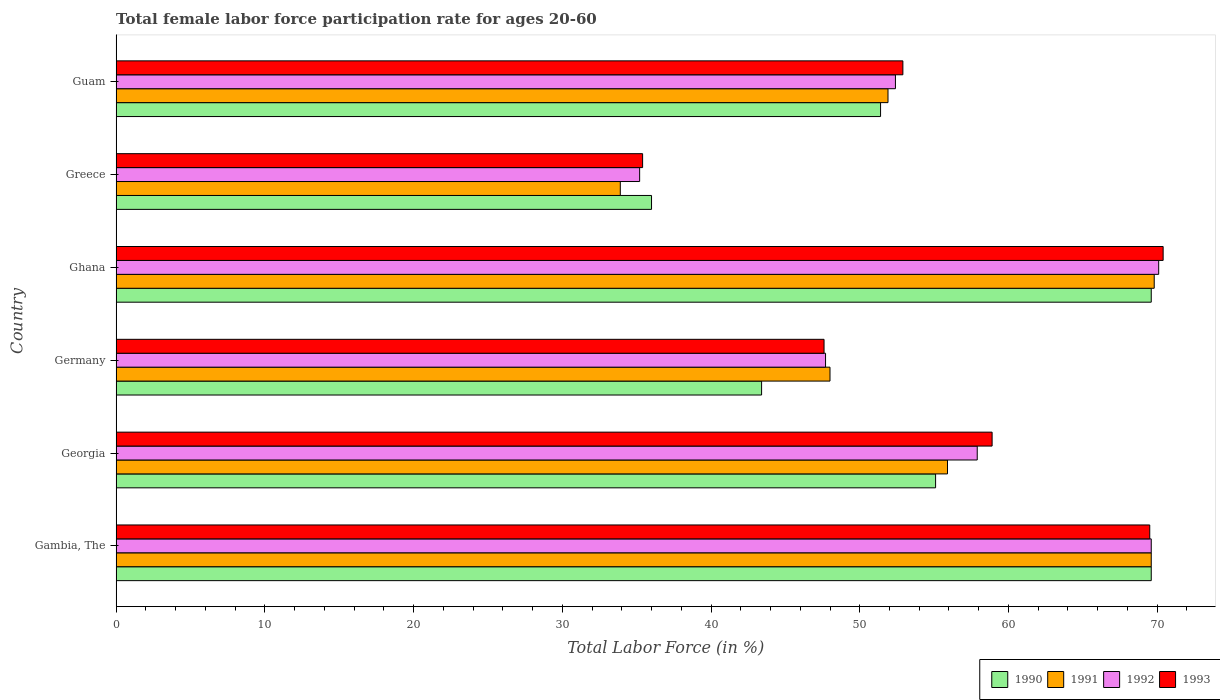How many different coloured bars are there?
Your response must be concise. 4. How many groups of bars are there?
Offer a very short reply. 6. Are the number of bars on each tick of the Y-axis equal?
Provide a short and direct response. Yes. How many bars are there on the 3rd tick from the top?
Make the answer very short. 4. What is the label of the 1st group of bars from the top?
Your answer should be very brief. Guam. In how many cases, is the number of bars for a given country not equal to the number of legend labels?
Offer a terse response. 0. What is the female labor force participation rate in 1992 in Gambia, The?
Offer a very short reply. 69.6. Across all countries, what is the maximum female labor force participation rate in 1993?
Offer a very short reply. 70.4. Across all countries, what is the minimum female labor force participation rate in 1991?
Offer a terse response. 33.9. In which country was the female labor force participation rate in 1990 minimum?
Make the answer very short. Greece. What is the total female labor force participation rate in 1991 in the graph?
Keep it short and to the point. 329.1. What is the average female labor force participation rate in 1991 per country?
Keep it short and to the point. 54.85. What is the difference between the female labor force participation rate in 1992 and female labor force participation rate in 1993 in Ghana?
Provide a succinct answer. -0.3. In how many countries, is the female labor force participation rate in 1990 greater than 34 %?
Keep it short and to the point. 6. What is the ratio of the female labor force participation rate in 1993 in Ghana to that in Greece?
Offer a terse response. 1.99. Is the female labor force participation rate in 1990 in Georgia less than that in Ghana?
Provide a short and direct response. Yes. What is the difference between the highest and the lowest female labor force participation rate in 1990?
Ensure brevity in your answer.  33.6. Is it the case that in every country, the sum of the female labor force participation rate in 1993 and female labor force participation rate in 1991 is greater than the sum of female labor force participation rate in 1992 and female labor force participation rate in 1990?
Keep it short and to the point. No. What does the 3rd bar from the top in Germany represents?
Your response must be concise. 1991. How many bars are there?
Offer a terse response. 24. Are all the bars in the graph horizontal?
Offer a terse response. Yes. What is the difference between two consecutive major ticks on the X-axis?
Give a very brief answer. 10. Are the values on the major ticks of X-axis written in scientific E-notation?
Make the answer very short. No. Does the graph contain any zero values?
Offer a very short reply. No. Does the graph contain grids?
Provide a succinct answer. No. Where does the legend appear in the graph?
Your answer should be very brief. Bottom right. How many legend labels are there?
Offer a terse response. 4. How are the legend labels stacked?
Provide a succinct answer. Horizontal. What is the title of the graph?
Give a very brief answer. Total female labor force participation rate for ages 20-60. What is the label or title of the X-axis?
Keep it short and to the point. Total Labor Force (in %). What is the label or title of the Y-axis?
Ensure brevity in your answer.  Country. What is the Total Labor Force (in %) of 1990 in Gambia, The?
Offer a terse response. 69.6. What is the Total Labor Force (in %) of 1991 in Gambia, The?
Provide a short and direct response. 69.6. What is the Total Labor Force (in %) of 1992 in Gambia, The?
Offer a very short reply. 69.6. What is the Total Labor Force (in %) in 1993 in Gambia, The?
Your answer should be very brief. 69.5. What is the Total Labor Force (in %) in 1990 in Georgia?
Give a very brief answer. 55.1. What is the Total Labor Force (in %) in 1991 in Georgia?
Make the answer very short. 55.9. What is the Total Labor Force (in %) in 1992 in Georgia?
Your response must be concise. 57.9. What is the Total Labor Force (in %) of 1993 in Georgia?
Make the answer very short. 58.9. What is the Total Labor Force (in %) in 1990 in Germany?
Your answer should be very brief. 43.4. What is the Total Labor Force (in %) of 1992 in Germany?
Provide a succinct answer. 47.7. What is the Total Labor Force (in %) in 1993 in Germany?
Your answer should be compact. 47.6. What is the Total Labor Force (in %) of 1990 in Ghana?
Provide a succinct answer. 69.6. What is the Total Labor Force (in %) in 1991 in Ghana?
Keep it short and to the point. 69.8. What is the Total Labor Force (in %) in 1992 in Ghana?
Provide a succinct answer. 70.1. What is the Total Labor Force (in %) in 1993 in Ghana?
Provide a succinct answer. 70.4. What is the Total Labor Force (in %) in 1991 in Greece?
Provide a succinct answer. 33.9. What is the Total Labor Force (in %) in 1992 in Greece?
Make the answer very short. 35.2. What is the Total Labor Force (in %) of 1993 in Greece?
Provide a short and direct response. 35.4. What is the Total Labor Force (in %) of 1990 in Guam?
Your response must be concise. 51.4. What is the Total Labor Force (in %) of 1991 in Guam?
Keep it short and to the point. 51.9. What is the Total Labor Force (in %) of 1992 in Guam?
Make the answer very short. 52.4. What is the Total Labor Force (in %) of 1993 in Guam?
Give a very brief answer. 52.9. Across all countries, what is the maximum Total Labor Force (in %) of 1990?
Keep it short and to the point. 69.6. Across all countries, what is the maximum Total Labor Force (in %) in 1991?
Offer a very short reply. 69.8. Across all countries, what is the maximum Total Labor Force (in %) of 1992?
Make the answer very short. 70.1. Across all countries, what is the maximum Total Labor Force (in %) of 1993?
Your answer should be very brief. 70.4. Across all countries, what is the minimum Total Labor Force (in %) of 1991?
Ensure brevity in your answer.  33.9. Across all countries, what is the minimum Total Labor Force (in %) of 1992?
Provide a succinct answer. 35.2. Across all countries, what is the minimum Total Labor Force (in %) of 1993?
Provide a short and direct response. 35.4. What is the total Total Labor Force (in %) of 1990 in the graph?
Offer a terse response. 325.1. What is the total Total Labor Force (in %) in 1991 in the graph?
Ensure brevity in your answer.  329.1. What is the total Total Labor Force (in %) of 1992 in the graph?
Offer a very short reply. 332.9. What is the total Total Labor Force (in %) of 1993 in the graph?
Provide a succinct answer. 334.7. What is the difference between the Total Labor Force (in %) of 1991 in Gambia, The and that in Georgia?
Provide a succinct answer. 13.7. What is the difference between the Total Labor Force (in %) of 1992 in Gambia, The and that in Georgia?
Ensure brevity in your answer.  11.7. What is the difference between the Total Labor Force (in %) in 1990 in Gambia, The and that in Germany?
Ensure brevity in your answer.  26.2. What is the difference between the Total Labor Force (in %) in 1991 in Gambia, The and that in Germany?
Keep it short and to the point. 21.6. What is the difference between the Total Labor Force (in %) of 1992 in Gambia, The and that in Germany?
Make the answer very short. 21.9. What is the difference between the Total Labor Force (in %) in 1993 in Gambia, The and that in Germany?
Your answer should be compact. 21.9. What is the difference between the Total Labor Force (in %) in 1990 in Gambia, The and that in Ghana?
Keep it short and to the point. 0. What is the difference between the Total Labor Force (in %) in 1991 in Gambia, The and that in Ghana?
Provide a short and direct response. -0.2. What is the difference between the Total Labor Force (in %) of 1990 in Gambia, The and that in Greece?
Offer a very short reply. 33.6. What is the difference between the Total Labor Force (in %) in 1991 in Gambia, The and that in Greece?
Your answer should be very brief. 35.7. What is the difference between the Total Labor Force (in %) in 1992 in Gambia, The and that in Greece?
Provide a short and direct response. 34.4. What is the difference between the Total Labor Force (in %) in 1993 in Gambia, The and that in Greece?
Ensure brevity in your answer.  34.1. What is the difference between the Total Labor Force (in %) in 1991 in Gambia, The and that in Guam?
Give a very brief answer. 17.7. What is the difference between the Total Labor Force (in %) of 1992 in Georgia and that in Germany?
Your answer should be compact. 10.2. What is the difference between the Total Labor Force (in %) in 1993 in Georgia and that in Germany?
Keep it short and to the point. 11.3. What is the difference between the Total Labor Force (in %) of 1992 in Georgia and that in Ghana?
Your response must be concise. -12.2. What is the difference between the Total Labor Force (in %) of 1993 in Georgia and that in Ghana?
Offer a terse response. -11.5. What is the difference between the Total Labor Force (in %) in 1992 in Georgia and that in Greece?
Ensure brevity in your answer.  22.7. What is the difference between the Total Labor Force (in %) in 1993 in Georgia and that in Greece?
Provide a short and direct response. 23.5. What is the difference between the Total Labor Force (in %) of 1991 in Georgia and that in Guam?
Make the answer very short. 4. What is the difference between the Total Labor Force (in %) in 1993 in Georgia and that in Guam?
Provide a succinct answer. 6. What is the difference between the Total Labor Force (in %) in 1990 in Germany and that in Ghana?
Your answer should be compact. -26.2. What is the difference between the Total Labor Force (in %) in 1991 in Germany and that in Ghana?
Offer a very short reply. -21.8. What is the difference between the Total Labor Force (in %) in 1992 in Germany and that in Ghana?
Offer a very short reply. -22.4. What is the difference between the Total Labor Force (in %) in 1993 in Germany and that in Ghana?
Ensure brevity in your answer.  -22.8. What is the difference between the Total Labor Force (in %) of 1990 in Germany and that in Greece?
Give a very brief answer. 7.4. What is the difference between the Total Labor Force (in %) of 1991 in Germany and that in Greece?
Your answer should be very brief. 14.1. What is the difference between the Total Labor Force (in %) in 1993 in Germany and that in Greece?
Your answer should be very brief. 12.2. What is the difference between the Total Labor Force (in %) of 1990 in Germany and that in Guam?
Offer a very short reply. -8. What is the difference between the Total Labor Force (in %) in 1992 in Germany and that in Guam?
Ensure brevity in your answer.  -4.7. What is the difference between the Total Labor Force (in %) of 1990 in Ghana and that in Greece?
Provide a succinct answer. 33.6. What is the difference between the Total Labor Force (in %) in 1991 in Ghana and that in Greece?
Your answer should be very brief. 35.9. What is the difference between the Total Labor Force (in %) in 1992 in Ghana and that in Greece?
Keep it short and to the point. 34.9. What is the difference between the Total Labor Force (in %) in 1990 in Ghana and that in Guam?
Your answer should be compact. 18.2. What is the difference between the Total Labor Force (in %) of 1992 in Ghana and that in Guam?
Your answer should be very brief. 17.7. What is the difference between the Total Labor Force (in %) in 1990 in Greece and that in Guam?
Keep it short and to the point. -15.4. What is the difference between the Total Labor Force (in %) of 1991 in Greece and that in Guam?
Provide a short and direct response. -18. What is the difference between the Total Labor Force (in %) in 1992 in Greece and that in Guam?
Keep it short and to the point. -17.2. What is the difference between the Total Labor Force (in %) in 1993 in Greece and that in Guam?
Offer a terse response. -17.5. What is the difference between the Total Labor Force (in %) in 1990 in Gambia, The and the Total Labor Force (in %) in 1991 in Georgia?
Offer a terse response. 13.7. What is the difference between the Total Labor Force (in %) of 1991 in Gambia, The and the Total Labor Force (in %) of 1993 in Georgia?
Make the answer very short. 10.7. What is the difference between the Total Labor Force (in %) of 1992 in Gambia, The and the Total Labor Force (in %) of 1993 in Georgia?
Your response must be concise. 10.7. What is the difference between the Total Labor Force (in %) of 1990 in Gambia, The and the Total Labor Force (in %) of 1991 in Germany?
Provide a succinct answer. 21.6. What is the difference between the Total Labor Force (in %) of 1990 in Gambia, The and the Total Labor Force (in %) of 1992 in Germany?
Provide a short and direct response. 21.9. What is the difference between the Total Labor Force (in %) in 1990 in Gambia, The and the Total Labor Force (in %) in 1993 in Germany?
Give a very brief answer. 22. What is the difference between the Total Labor Force (in %) of 1991 in Gambia, The and the Total Labor Force (in %) of 1992 in Germany?
Your response must be concise. 21.9. What is the difference between the Total Labor Force (in %) in 1990 in Gambia, The and the Total Labor Force (in %) in 1991 in Ghana?
Provide a succinct answer. -0.2. What is the difference between the Total Labor Force (in %) in 1992 in Gambia, The and the Total Labor Force (in %) in 1993 in Ghana?
Your answer should be very brief. -0.8. What is the difference between the Total Labor Force (in %) of 1990 in Gambia, The and the Total Labor Force (in %) of 1991 in Greece?
Your answer should be compact. 35.7. What is the difference between the Total Labor Force (in %) of 1990 in Gambia, The and the Total Labor Force (in %) of 1992 in Greece?
Offer a terse response. 34.4. What is the difference between the Total Labor Force (in %) of 1990 in Gambia, The and the Total Labor Force (in %) of 1993 in Greece?
Your answer should be compact. 34.2. What is the difference between the Total Labor Force (in %) of 1991 in Gambia, The and the Total Labor Force (in %) of 1992 in Greece?
Provide a short and direct response. 34.4. What is the difference between the Total Labor Force (in %) of 1991 in Gambia, The and the Total Labor Force (in %) of 1993 in Greece?
Ensure brevity in your answer.  34.2. What is the difference between the Total Labor Force (in %) in 1992 in Gambia, The and the Total Labor Force (in %) in 1993 in Greece?
Make the answer very short. 34.2. What is the difference between the Total Labor Force (in %) of 1990 in Gambia, The and the Total Labor Force (in %) of 1991 in Guam?
Your response must be concise. 17.7. What is the difference between the Total Labor Force (in %) in 1990 in Gambia, The and the Total Labor Force (in %) in 1993 in Guam?
Your response must be concise. 16.7. What is the difference between the Total Labor Force (in %) of 1991 in Gambia, The and the Total Labor Force (in %) of 1993 in Guam?
Provide a short and direct response. 16.7. What is the difference between the Total Labor Force (in %) in 1990 in Georgia and the Total Labor Force (in %) in 1992 in Germany?
Keep it short and to the point. 7.4. What is the difference between the Total Labor Force (in %) in 1991 in Georgia and the Total Labor Force (in %) in 1993 in Germany?
Provide a succinct answer. 8.3. What is the difference between the Total Labor Force (in %) of 1992 in Georgia and the Total Labor Force (in %) of 1993 in Germany?
Offer a terse response. 10.3. What is the difference between the Total Labor Force (in %) of 1990 in Georgia and the Total Labor Force (in %) of 1991 in Ghana?
Offer a very short reply. -14.7. What is the difference between the Total Labor Force (in %) of 1990 in Georgia and the Total Labor Force (in %) of 1993 in Ghana?
Offer a terse response. -15.3. What is the difference between the Total Labor Force (in %) of 1991 in Georgia and the Total Labor Force (in %) of 1992 in Ghana?
Your answer should be very brief. -14.2. What is the difference between the Total Labor Force (in %) in 1991 in Georgia and the Total Labor Force (in %) in 1993 in Ghana?
Keep it short and to the point. -14.5. What is the difference between the Total Labor Force (in %) of 1992 in Georgia and the Total Labor Force (in %) of 1993 in Ghana?
Your answer should be compact. -12.5. What is the difference between the Total Labor Force (in %) in 1990 in Georgia and the Total Labor Force (in %) in 1991 in Greece?
Ensure brevity in your answer.  21.2. What is the difference between the Total Labor Force (in %) in 1990 in Georgia and the Total Labor Force (in %) in 1992 in Greece?
Ensure brevity in your answer.  19.9. What is the difference between the Total Labor Force (in %) in 1990 in Georgia and the Total Labor Force (in %) in 1993 in Greece?
Your response must be concise. 19.7. What is the difference between the Total Labor Force (in %) in 1991 in Georgia and the Total Labor Force (in %) in 1992 in Greece?
Offer a terse response. 20.7. What is the difference between the Total Labor Force (in %) of 1990 in Georgia and the Total Labor Force (in %) of 1991 in Guam?
Offer a terse response. 3.2. What is the difference between the Total Labor Force (in %) of 1991 in Georgia and the Total Labor Force (in %) of 1992 in Guam?
Give a very brief answer. 3.5. What is the difference between the Total Labor Force (in %) of 1990 in Germany and the Total Labor Force (in %) of 1991 in Ghana?
Make the answer very short. -26.4. What is the difference between the Total Labor Force (in %) of 1990 in Germany and the Total Labor Force (in %) of 1992 in Ghana?
Your answer should be compact. -26.7. What is the difference between the Total Labor Force (in %) in 1991 in Germany and the Total Labor Force (in %) in 1992 in Ghana?
Give a very brief answer. -22.1. What is the difference between the Total Labor Force (in %) in 1991 in Germany and the Total Labor Force (in %) in 1993 in Ghana?
Offer a very short reply. -22.4. What is the difference between the Total Labor Force (in %) of 1992 in Germany and the Total Labor Force (in %) of 1993 in Ghana?
Make the answer very short. -22.7. What is the difference between the Total Labor Force (in %) of 1990 in Germany and the Total Labor Force (in %) of 1991 in Greece?
Your answer should be very brief. 9.5. What is the difference between the Total Labor Force (in %) of 1990 in Germany and the Total Labor Force (in %) of 1992 in Greece?
Your answer should be very brief. 8.2. What is the difference between the Total Labor Force (in %) in 1990 in Germany and the Total Labor Force (in %) in 1993 in Greece?
Provide a succinct answer. 8. What is the difference between the Total Labor Force (in %) in 1991 in Germany and the Total Labor Force (in %) in 1992 in Greece?
Offer a very short reply. 12.8. What is the difference between the Total Labor Force (in %) of 1992 in Germany and the Total Labor Force (in %) of 1993 in Greece?
Offer a terse response. 12.3. What is the difference between the Total Labor Force (in %) in 1990 in Germany and the Total Labor Force (in %) in 1991 in Guam?
Provide a succinct answer. -8.5. What is the difference between the Total Labor Force (in %) in 1990 in Germany and the Total Labor Force (in %) in 1992 in Guam?
Offer a very short reply. -9. What is the difference between the Total Labor Force (in %) of 1990 in Germany and the Total Labor Force (in %) of 1993 in Guam?
Ensure brevity in your answer.  -9.5. What is the difference between the Total Labor Force (in %) of 1991 in Germany and the Total Labor Force (in %) of 1992 in Guam?
Provide a succinct answer. -4.4. What is the difference between the Total Labor Force (in %) in 1991 in Germany and the Total Labor Force (in %) in 1993 in Guam?
Offer a terse response. -4.9. What is the difference between the Total Labor Force (in %) of 1992 in Germany and the Total Labor Force (in %) of 1993 in Guam?
Your response must be concise. -5.2. What is the difference between the Total Labor Force (in %) of 1990 in Ghana and the Total Labor Force (in %) of 1991 in Greece?
Offer a very short reply. 35.7. What is the difference between the Total Labor Force (in %) of 1990 in Ghana and the Total Labor Force (in %) of 1992 in Greece?
Your response must be concise. 34.4. What is the difference between the Total Labor Force (in %) in 1990 in Ghana and the Total Labor Force (in %) in 1993 in Greece?
Offer a terse response. 34.2. What is the difference between the Total Labor Force (in %) of 1991 in Ghana and the Total Labor Force (in %) of 1992 in Greece?
Your response must be concise. 34.6. What is the difference between the Total Labor Force (in %) of 1991 in Ghana and the Total Labor Force (in %) of 1993 in Greece?
Your answer should be compact. 34.4. What is the difference between the Total Labor Force (in %) of 1992 in Ghana and the Total Labor Force (in %) of 1993 in Greece?
Give a very brief answer. 34.7. What is the difference between the Total Labor Force (in %) in 1990 in Ghana and the Total Labor Force (in %) in 1992 in Guam?
Keep it short and to the point. 17.2. What is the difference between the Total Labor Force (in %) of 1992 in Ghana and the Total Labor Force (in %) of 1993 in Guam?
Offer a very short reply. 17.2. What is the difference between the Total Labor Force (in %) in 1990 in Greece and the Total Labor Force (in %) in 1991 in Guam?
Make the answer very short. -15.9. What is the difference between the Total Labor Force (in %) in 1990 in Greece and the Total Labor Force (in %) in 1992 in Guam?
Provide a succinct answer. -16.4. What is the difference between the Total Labor Force (in %) of 1990 in Greece and the Total Labor Force (in %) of 1993 in Guam?
Provide a short and direct response. -16.9. What is the difference between the Total Labor Force (in %) of 1991 in Greece and the Total Labor Force (in %) of 1992 in Guam?
Offer a very short reply. -18.5. What is the difference between the Total Labor Force (in %) of 1992 in Greece and the Total Labor Force (in %) of 1993 in Guam?
Offer a very short reply. -17.7. What is the average Total Labor Force (in %) of 1990 per country?
Provide a succinct answer. 54.18. What is the average Total Labor Force (in %) in 1991 per country?
Provide a succinct answer. 54.85. What is the average Total Labor Force (in %) of 1992 per country?
Offer a terse response. 55.48. What is the average Total Labor Force (in %) of 1993 per country?
Provide a short and direct response. 55.78. What is the difference between the Total Labor Force (in %) in 1990 and Total Labor Force (in %) in 1991 in Gambia, The?
Provide a succinct answer. 0. What is the difference between the Total Labor Force (in %) in 1990 and Total Labor Force (in %) in 1992 in Gambia, The?
Ensure brevity in your answer.  0. What is the difference between the Total Labor Force (in %) of 1991 and Total Labor Force (in %) of 1993 in Gambia, The?
Offer a very short reply. 0.1. What is the difference between the Total Labor Force (in %) of 1992 and Total Labor Force (in %) of 1993 in Gambia, The?
Ensure brevity in your answer.  0.1. What is the difference between the Total Labor Force (in %) of 1990 and Total Labor Force (in %) of 1991 in Georgia?
Your answer should be compact. -0.8. What is the difference between the Total Labor Force (in %) in 1990 and Total Labor Force (in %) in 1993 in Georgia?
Keep it short and to the point. -3.8. What is the difference between the Total Labor Force (in %) of 1992 and Total Labor Force (in %) of 1993 in Georgia?
Provide a short and direct response. -1. What is the difference between the Total Labor Force (in %) in 1990 and Total Labor Force (in %) in 1991 in Germany?
Your answer should be very brief. -4.6. What is the difference between the Total Labor Force (in %) in 1990 and Total Labor Force (in %) in 1992 in Germany?
Keep it short and to the point. -4.3. What is the difference between the Total Labor Force (in %) in 1990 and Total Labor Force (in %) in 1993 in Ghana?
Offer a very short reply. -0.8. What is the difference between the Total Labor Force (in %) in 1991 and Total Labor Force (in %) in 1992 in Ghana?
Provide a short and direct response. -0.3. What is the difference between the Total Labor Force (in %) of 1992 and Total Labor Force (in %) of 1993 in Ghana?
Offer a very short reply. -0.3. What is the difference between the Total Labor Force (in %) of 1990 and Total Labor Force (in %) of 1992 in Greece?
Ensure brevity in your answer.  0.8. What is the difference between the Total Labor Force (in %) of 1990 and Total Labor Force (in %) of 1993 in Greece?
Keep it short and to the point. 0.6. What is the difference between the Total Labor Force (in %) of 1991 and Total Labor Force (in %) of 1993 in Greece?
Your response must be concise. -1.5. What is the difference between the Total Labor Force (in %) in 1992 and Total Labor Force (in %) in 1993 in Greece?
Provide a succinct answer. -0.2. What is the difference between the Total Labor Force (in %) in 1990 and Total Labor Force (in %) in 1991 in Guam?
Give a very brief answer. -0.5. What is the difference between the Total Labor Force (in %) in 1990 and Total Labor Force (in %) in 1993 in Guam?
Provide a succinct answer. -1.5. What is the difference between the Total Labor Force (in %) in 1992 and Total Labor Force (in %) in 1993 in Guam?
Your answer should be very brief. -0.5. What is the ratio of the Total Labor Force (in %) in 1990 in Gambia, The to that in Georgia?
Your answer should be compact. 1.26. What is the ratio of the Total Labor Force (in %) of 1991 in Gambia, The to that in Georgia?
Your answer should be very brief. 1.25. What is the ratio of the Total Labor Force (in %) in 1992 in Gambia, The to that in Georgia?
Give a very brief answer. 1.2. What is the ratio of the Total Labor Force (in %) of 1993 in Gambia, The to that in Georgia?
Keep it short and to the point. 1.18. What is the ratio of the Total Labor Force (in %) in 1990 in Gambia, The to that in Germany?
Give a very brief answer. 1.6. What is the ratio of the Total Labor Force (in %) in 1991 in Gambia, The to that in Germany?
Your answer should be very brief. 1.45. What is the ratio of the Total Labor Force (in %) of 1992 in Gambia, The to that in Germany?
Provide a short and direct response. 1.46. What is the ratio of the Total Labor Force (in %) in 1993 in Gambia, The to that in Germany?
Keep it short and to the point. 1.46. What is the ratio of the Total Labor Force (in %) of 1990 in Gambia, The to that in Ghana?
Offer a terse response. 1. What is the ratio of the Total Labor Force (in %) of 1991 in Gambia, The to that in Ghana?
Make the answer very short. 1. What is the ratio of the Total Labor Force (in %) of 1992 in Gambia, The to that in Ghana?
Offer a terse response. 0.99. What is the ratio of the Total Labor Force (in %) in 1993 in Gambia, The to that in Ghana?
Make the answer very short. 0.99. What is the ratio of the Total Labor Force (in %) in 1990 in Gambia, The to that in Greece?
Your answer should be very brief. 1.93. What is the ratio of the Total Labor Force (in %) in 1991 in Gambia, The to that in Greece?
Your answer should be very brief. 2.05. What is the ratio of the Total Labor Force (in %) in 1992 in Gambia, The to that in Greece?
Offer a terse response. 1.98. What is the ratio of the Total Labor Force (in %) in 1993 in Gambia, The to that in Greece?
Provide a succinct answer. 1.96. What is the ratio of the Total Labor Force (in %) of 1990 in Gambia, The to that in Guam?
Make the answer very short. 1.35. What is the ratio of the Total Labor Force (in %) in 1991 in Gambia, The to that in Guam?
Offer a very short reply. 1.34. What is the ratio of the Total Labor Force (in %) in 1992 in Gambia, The to that in Guam?
Provide a succinct answer. 1.33. What is the ratio of the Total Labor Force (in %) in 1993 in Gambia, The to that in Guam?
Keep it short and to the point. 1.31. What is the ratio of the Total Labor Force (in %) in 1990 in Georgia to that in Germany?
Your answer should be very brief. 1.27. What is the ratio of the Total Labor Force (in %) in 1991 in Georgia to that in Germany?
Give a very brief answer. 1.16. What is the ratio of the Total Labor Force (in %) of 1992 in Georgia to that in Germany?
Ensure brevity in your answer.  1.21. What is the ratio of the Total Labor Force (in %) of 1993 in Georgia to that in Germany?
Your answer should be very brief. 1.24. What is the ratio of the Total Labor Force (in %) of 1990 in Georgia to that in Ghana?
Offer a very short reply. 0.79. What is the ratio of the Total Labor Force (in %) in 1991 in Georgia to that in Ghana?
Give a very brief answer. 0.8. What is the ratio of the Total Labor Force (in %) in 1992 in Georgia to that in Ghana?
Your answer should be compact. 0.83. What is the ratio of the Total Labor Force (in %) of 1993 in Georgia to that in Ghana?
Make the answer very short. 0.84. What is the ratio of the Total Labor Force (in %) of 1990 in Georgia to that in Greece?
Ensure brevity in your answer.  1.53. What is the ratio of the Total Labor Force (in %) of 1991 in Georgia to that in Greece?
Offer a terse response. 1.65. What is the ratio of the Total Labor Force (in %) of 1992 in Georgia to that in Greece?
Your response must be concise. 1.64. What is the ratio of the Total Labor Force (in %) in 1993 in Georgia to that in Greece?
Give a very brief answer. 1.66. What is the ratio of the Total Labor Force (in %) of 1990 in Georgia to that in Guam?
Your answer should be very brief. 1.07. What is the ratio of the Total Labor Force (in %) of 1991 in Georgia to that in Guam?
Ensure brevity in your answer.  1.08. What is the ratio of the Total Labor Force (in %) in 1992 in Georgia to that in Guam?
Offer a terse response. 1.1. What is the ratio of the Total Labor Force (in %) in 1993 in Georgia to that in Guam?
Offer a terse response. 1.11. What is the ratio of the Total Labor Force (in %) of 1990 in Germany to that in Ghana?
Offer a very short reply. 0.62. What is the ratio of the Total Labor Force (in %) in 1991 in Germany to that in Ghana?
Provide a succinct answer. 0.69. What is the ratio of the Total Labor Force (in %) of 1992 in Germany to that in Ghana?
Provide a short and direct response. 0.68. What is the ratio of the Total Labor Force (in %) of 1993 in Germany to that in Ghana?
Your answer should be very brief. 0.68. What is the ratio of the Total Labor Force (in %) of 1990 in Germany to that in Greece?
Offer a very short reply. 1.21. What is the ratio of the Total Labor Force (in %) in 1991 in Germany to that in Greece?
Your answer should be very brief. 1.42. What is the ratio of the Total Labor Force (in %) of 1992 in Germany to that in Greece?
Give a very brief answer. 1.36. What is the ratio of the Total Labor Force (in %) in 1993 in Germany to that in Greece?
Offer a terse response. 1.34. What is the ratio of the Total Labor Force (in %) in 1990 in Germany to that in Guam?
Your answer should be compact. 0.84. What is the ratio of the Total Labor Force (in %) of 1991 in Germany to that in Guam?
Offer a very short reply. 0.92. What is the ratio of the Total Labor Force (in %) in 1992 in Germany to that in Guam?
Provide a short and direct response. 0.91. What is the ratio of the Total Labor Force (in %) in 1993 in Germany to that in Guam?
Your answer should be very brief. 0.9. What is the ratio of the Total Labor Force (in %) in 1990 in Ghana to that in Greece?
Your answer should be very brief. 1.93. What is the ratio of the Total Labor Force (in %) of 1991 in Ghana to that in Greece?
Give a very brief answer. 2.06. What is the ratio of the Total Labor Force (in %) in 1992 in Ghana to that in Greece?
Make the answer very short. 1.99. What is the ratio of the Total Labor Force (in %) in 1993 in Ghana to that in Greece?
Provide a succinct answer. 1.99. What is the ratio of the Total Labor Force (in %) of 1990 in Ghana to that in Guam?
Offer a very short reply. 1.35. What is the ratio of the Total Labor Force (in %) of 1991 in Ghana to that in Guam?
Keep it short and to the point. 1.34. What is the ratio of the Total Labor Force (in %) in 1992 in Ghana to that in Guam?
Provide a short and direct response. 1.34. What is the ratio of the Total Labor Force (in %) in 1993 in Ghana to that in Guam?
Offer a very short reply. 1.33. What is the ratio of the Total Labor Force (in %) of 1990 in Greece to that in Guam?
Provide a succinct answer. 0.7. What is the ratio of the Total Labor Force (in %) of 1991 in Greece to that in Guam?
Keep it short and to the point. 0.65. What is the ratio of the Total Labor Force (in %) in 1992 in Greece to that in Guam?
Offer a very short reply. 0.67. What is the ratio of the Total Labor Force (in %) in 1993 in Greece to that in Guam?
Provide a succinct answer. 0.67. What is the difference between the highest and the second highest Total Labor Force (in %) in 1991?
Keep it short and to the point. 0.2. What is the difference between the highest and the second highest Total Labor Force (in %) in 1992?
Your answer should be very brief. 0.5. What is the difference between the highest and the second highest Total Labor Force (in %) of 1993?
Ensure brevity in your answer.  0.9. What is the difference between the highest and the lowest Total Labor Force (in %) of 1990?
Offer a terse response. 33.6. What is the difference between the highest and the lowest Total Labor Force (in %) in 1991?
Your answer should be very brief. 35.9. What is the difference between the highest and the lowest Total Labor Force (in %) of 1992?
Ensure brevity in your answer.  34.9. 